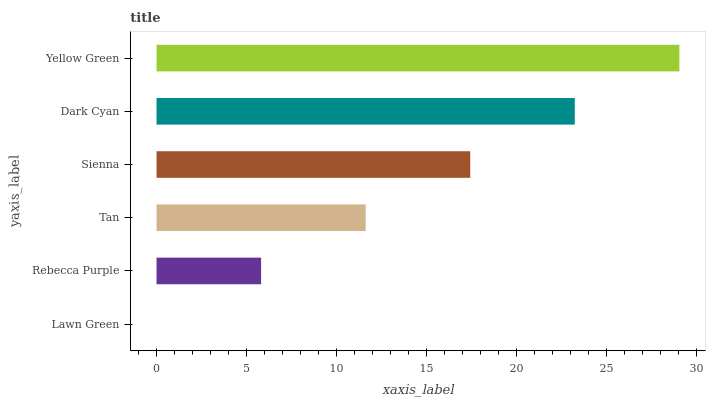Is Lawn Green the minimum?
Answer yes or no. Yes. Is Yellow Green the maximum?
Answer yes or no. Yes. Is Rebecca Purple the minimum?
Answer yes or no. No. Is Rebecca Purple the maximum?
Answer yes or no. No. Is Rebecca Purple greater than Lawn Green?
Answer yes or no. Yes. Is Lawn Green less than Rebecca Purple?
Answer yes or no. Yes. Is Lawn Green greater than Rebecca Purple?
Answer yes or no. No. Is Rebecca Purple less than Lawn Green?
Answer yes or no. No. Is Sienna the high median?
Answer yes or no. Yes. Is Tan the low median?
Answer yes or no. Yes. Is Lawn Green the high median?
Answer yes or no. No. Is Lawn Green the low median?
Answer yes or no. No. 